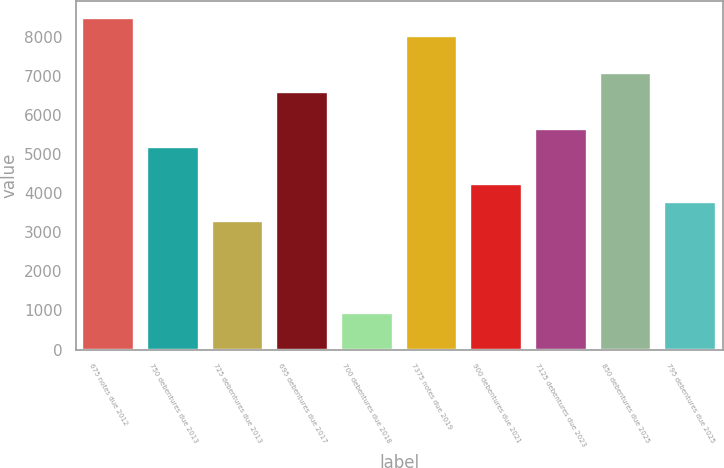<chart> <loc_0><loc_0><loc_500><loc_500><bar_chart><fcel>675 notes due 2012<fcel>750 debentures due 2013<fcel>725 debentures due 2013<fcel>695 debentures due 2017<fcel>700 debentures due 2018<fcel>7375 notes due 2019<fcel>900 debentures due 2021<fcel>7125 debentures due 2023<fcel>850 debentures due 2025<fcel>795 debentures due 2025<nl><fcel>8477.2<fcel>5180.9<fcel>3297.3<fcel>6593.6<fcel>942.8<fcel>8006.3<fcel>4239.1<fcel>5651.8<fcel>7064.5<fcel>3768.2<nl></chart> 